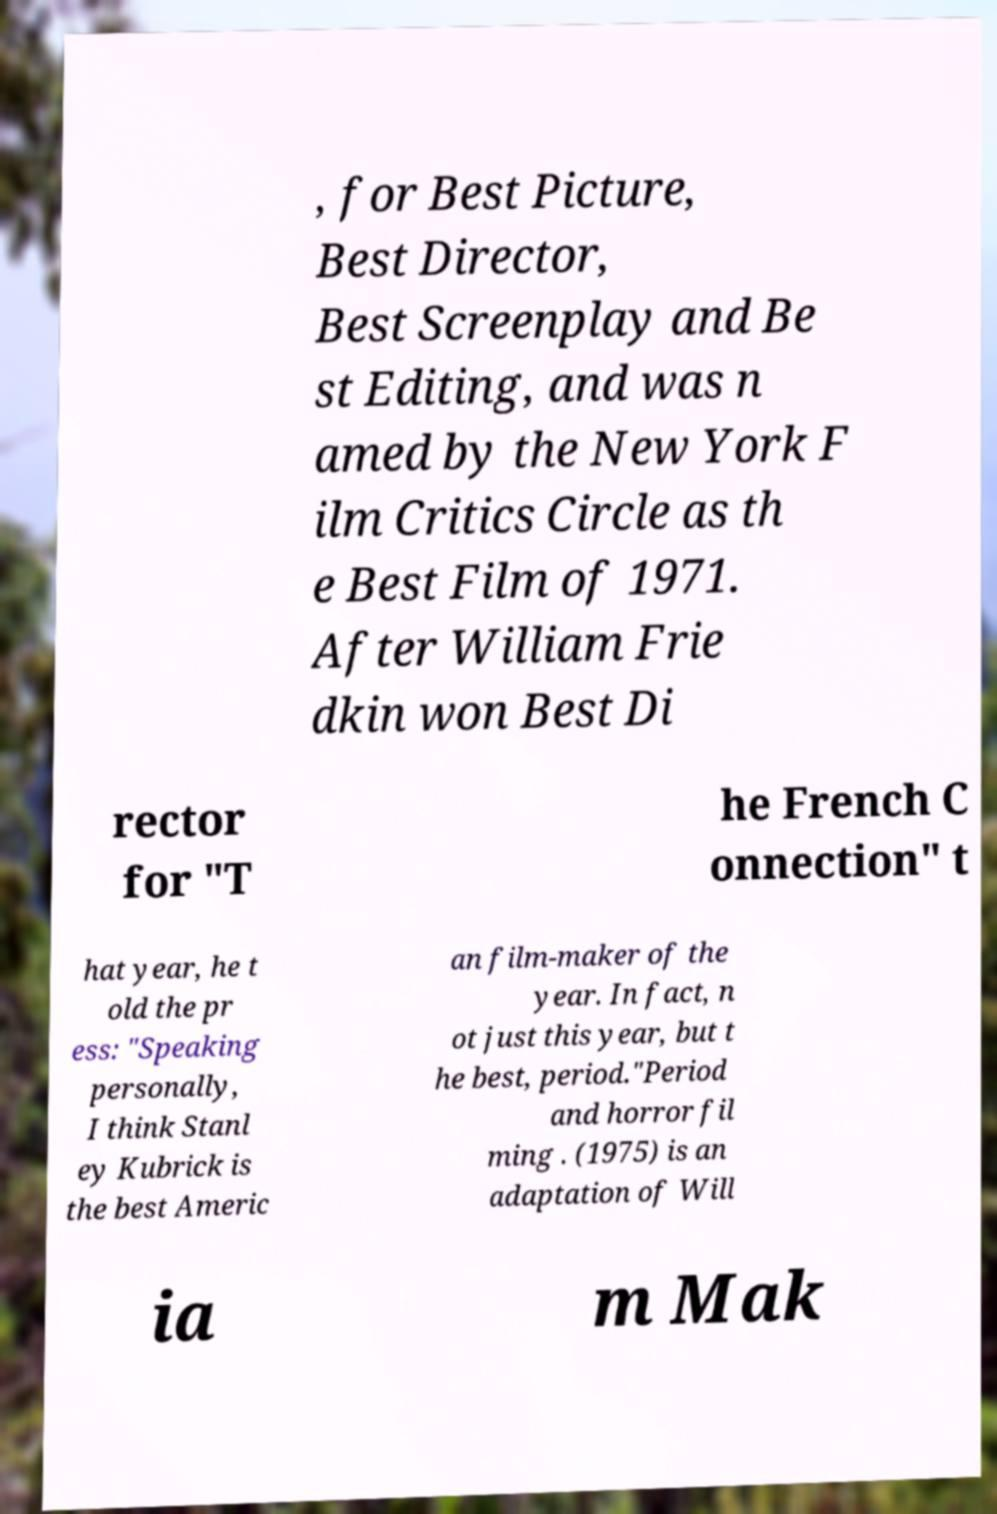Please read and relay the text visible in this image. What does it say? , for Best Picture, Best Director, Best Screenplay and Be st Editing, and was n amed by the New York F ilm Critics Circle as th e Best Film of 1971. After William Frie dkin won Best Di rector for "T he French C onnection" t hat year, he t old the pr ess: "Speaking personally, I think Stanl ey Kubrick is the best Americ an film-maker of the year. In fact, n ot just this year, but t he best, period."Period and horror fil ming . (1975) is an adaptation of Will ia m Mak 